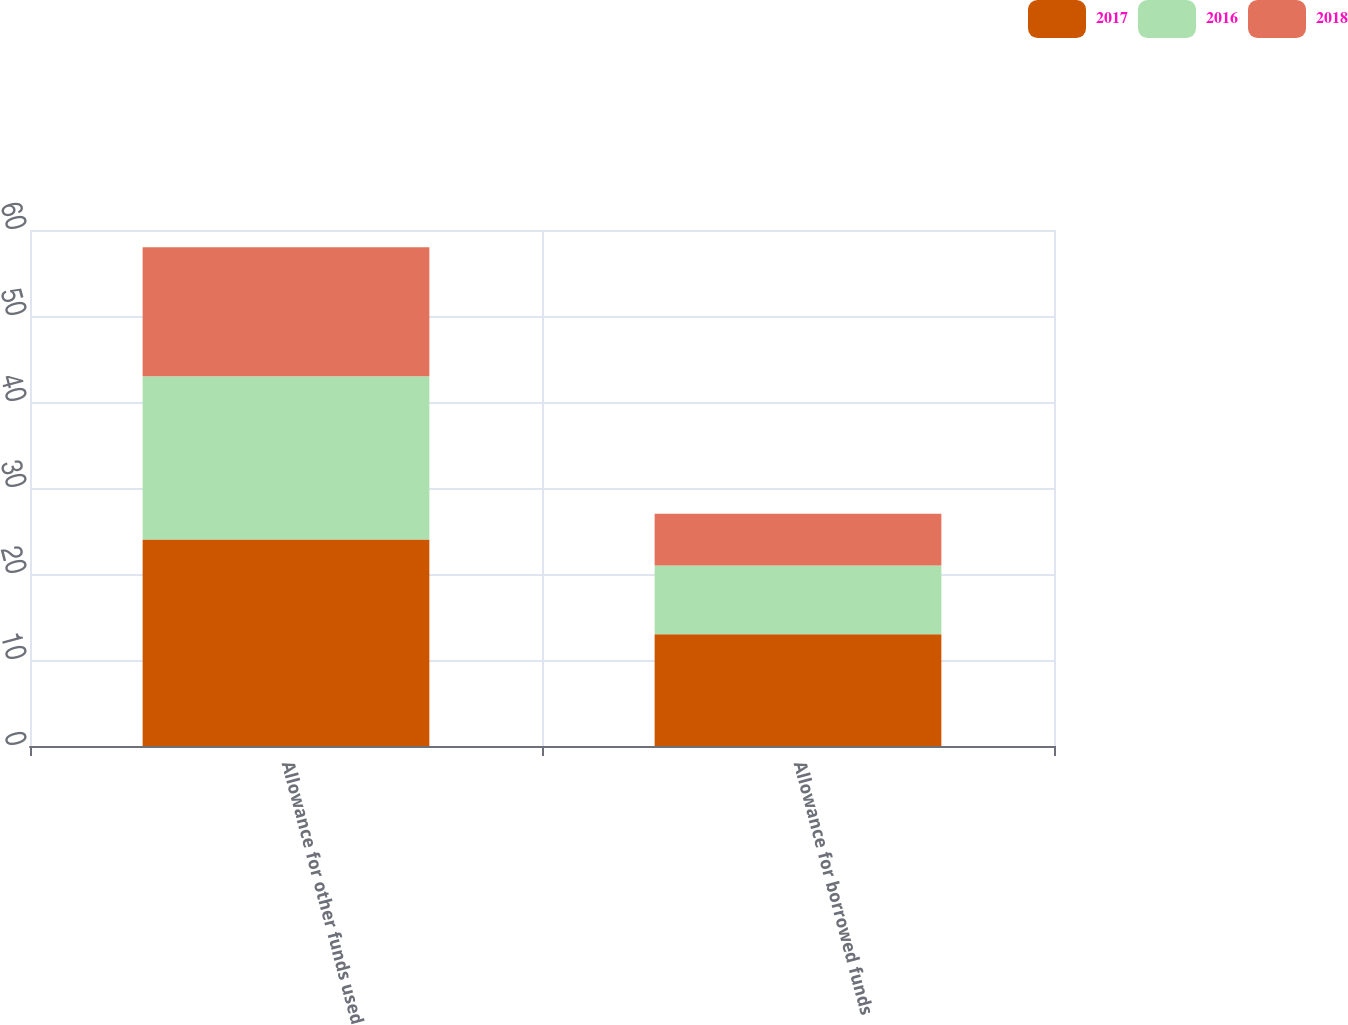Convert chart. <chart><loc_0><loc_0><loc_500><loc_500><stacked_bar_chart><ecel><fcel>Allowance for other funds used<fcel>Allowance for borrowed funds<nl><fcel>2017<fcel>24<fcel>13<nl><fcel>2016<fcel>19<fcel>8<nl><fcel>2018<fcel>15<fcel>6<nl></chart> 